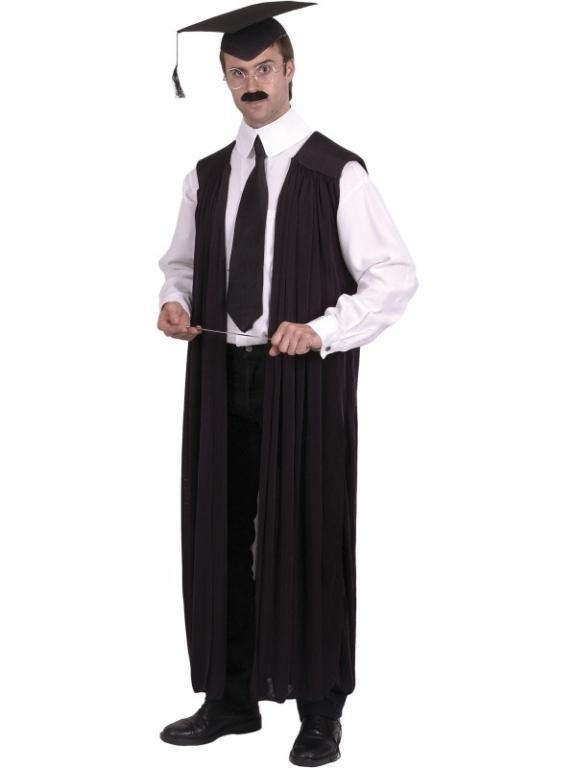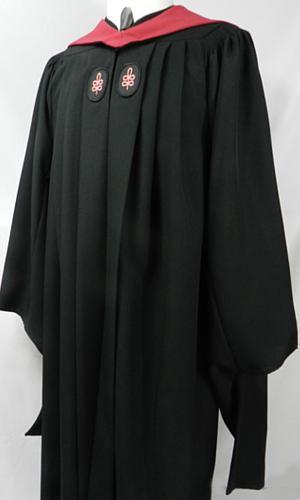The first image is the image on the left, the second image is the image on the right. For the images shown, is this caption "One image shows a graduation outfit modeled by a real man, and the other image contains at least one graduation robe on a headless mannequin form." true? Answer yes or no. Yes. The first image is the image on the left, the second image is the image on the right. Evaluate the accuracy of this statement regarding the images: "Each of the graduation gowns is being modeled by an actual person.". Is it true? Answer yes or no. No. 